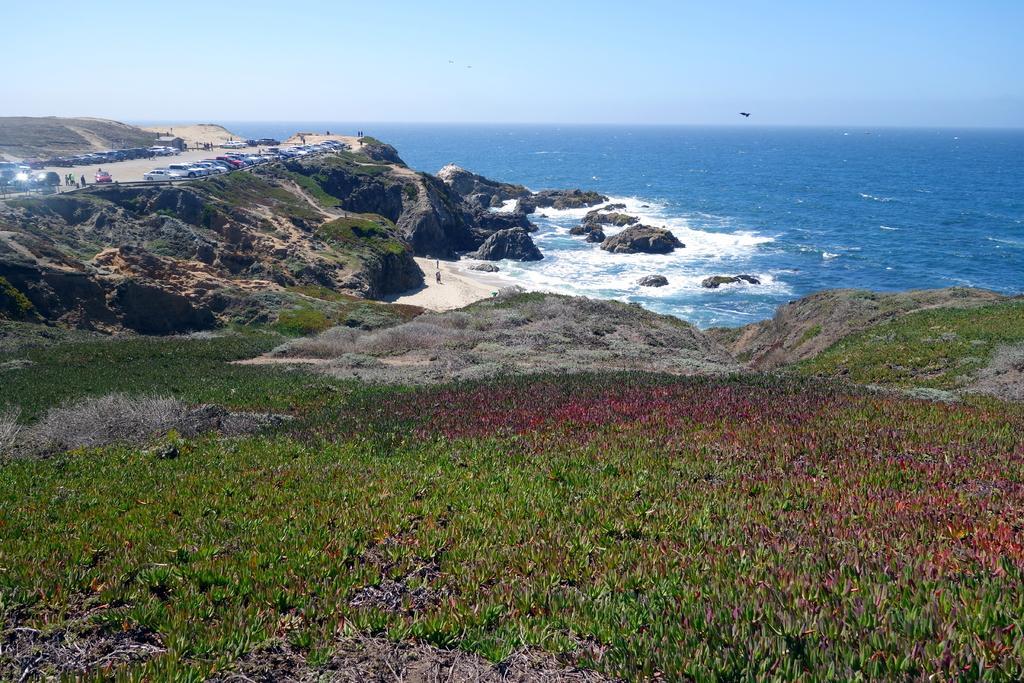Please provide a concise description of this image. In this picture we can see vehicles on the road, grass, rocks, water and in the background we can see the sky. 